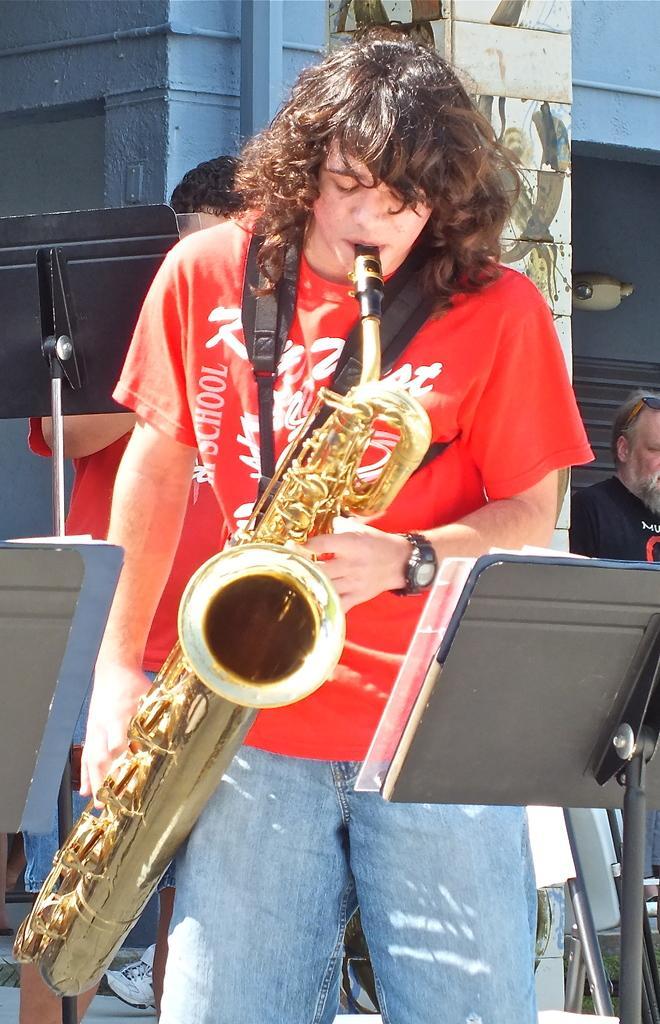Describe this image in one or two sentences. In this picture there is a man standing and playing musical instrument, in front of him we can see a stand. In the background of the image we can see people, stand, wall and objects. 